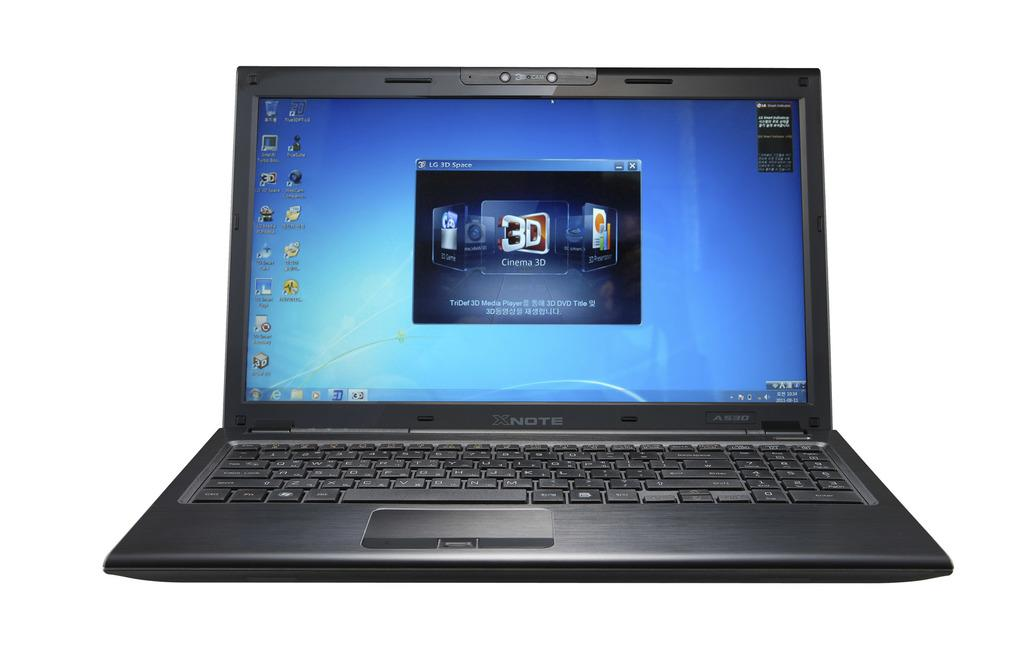What type of electronic device is visible in the image? There is a black color laptop in the image. What can be seen on the laptop's screen? The laptop's screen has writing on it. What color is the background of the image? The background of the image is white. What type of fuel is being used by the dog on the side of the image? There is no dog present in the image, and therefore no fuel usage can be observed. 